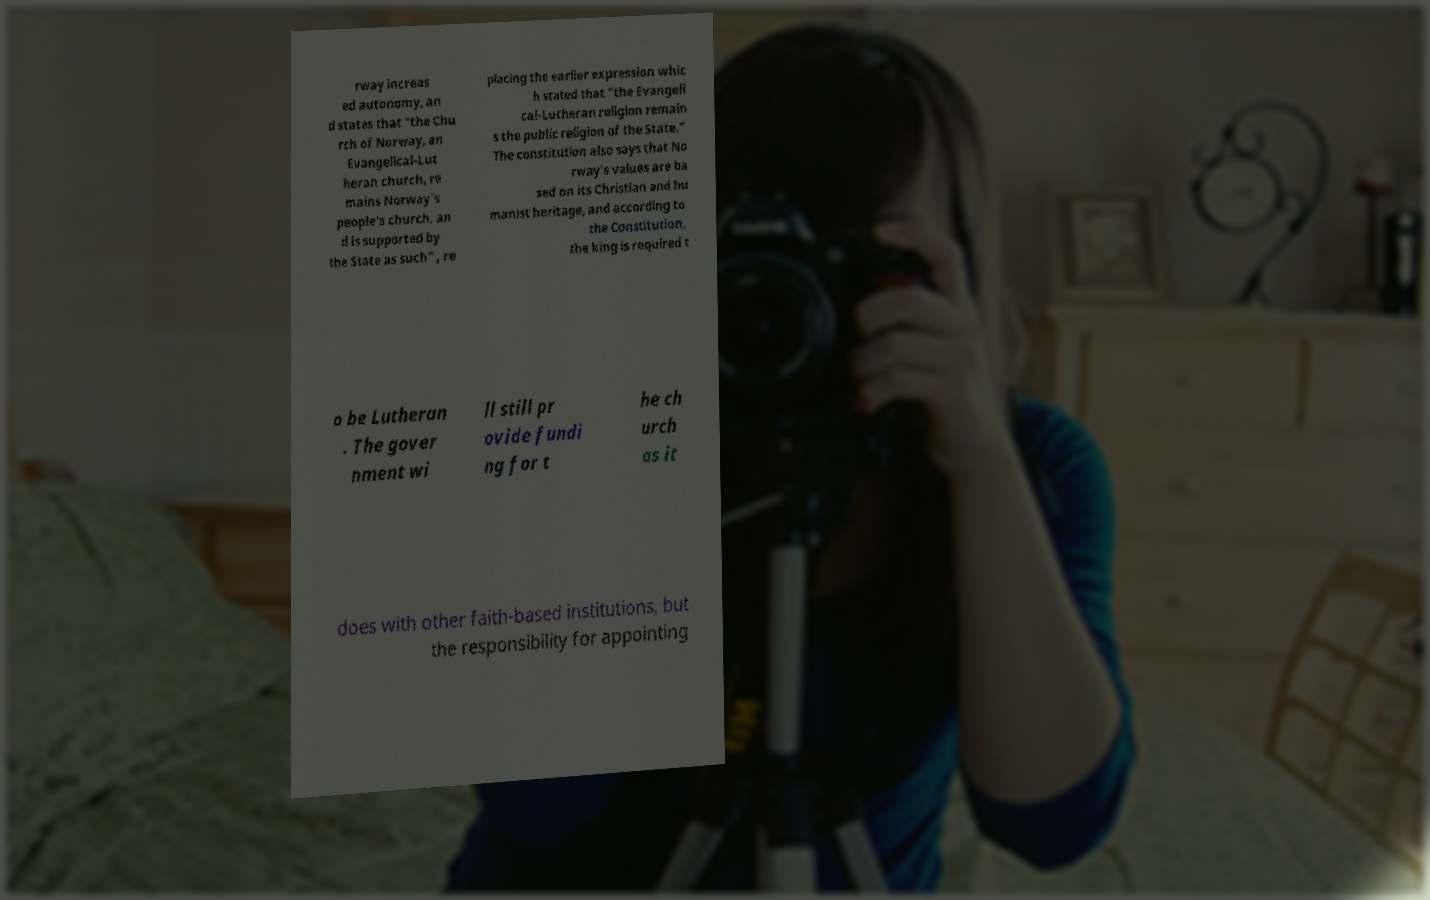What messages or text are displayed in this image? I need them in a readable, typed format. rway increas ed autonomy, an d states that "the Chu rch of Norway, an Evangelical-Lut heran church, re mains Norway's people's church, an d is supported by the State as such" , re placing the earlier expression whic h stated that "the Evangeli cal-Lutheran religion remain s the public religion of the State." The constitution also says that No rway's values are ba sed on its Christian and hu manist heritage, and according to the Constitution, the king is required t o be Lutheran . The gover nment wi ll still pr ovide fundi ng for t he ch urch as it does with other faith-based institutions, but the responsibility for appointing 